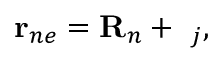Convert formula to latex. <formula><loc_0><loc_0><loc_500><loc_500>{ r } _ { n e } = { R } _ { n } + { \rho } _ { j } ,</formula> 